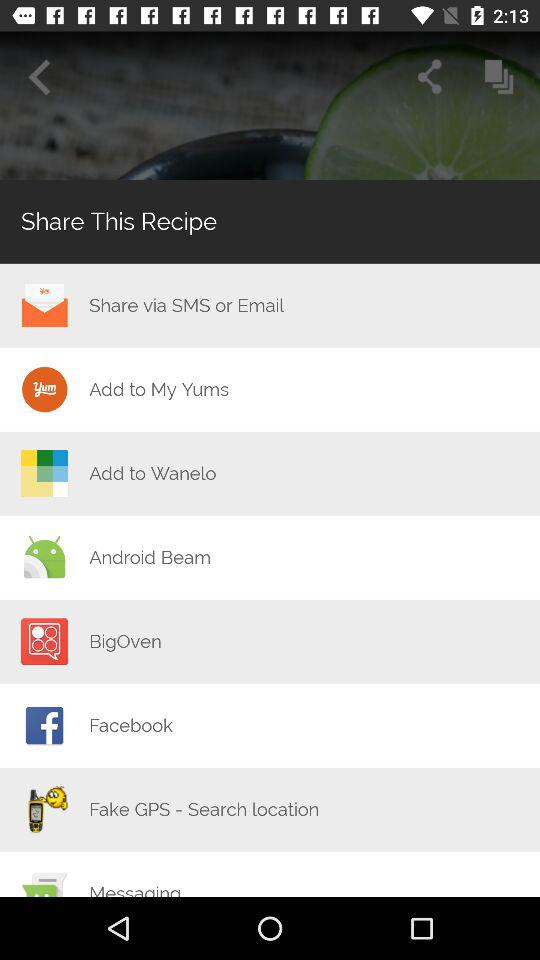Through which app can I share this recipe? You can share this recipe with "SMS", "Email", "My Yums", "Wanelo", "Android Beam", "BigOven", "Facebook" and "Fake GPS - Search location". 